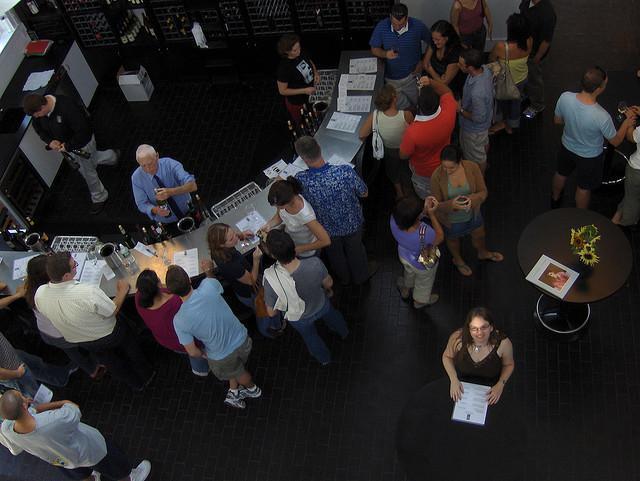What are most people gathered around?
Choose the correct response and explain in the format: 'Answer: answer
Rationale: rationale.'
Options: Table, bar, library, kitchen. Answer: bar.
Rationale: They are around a bar. 